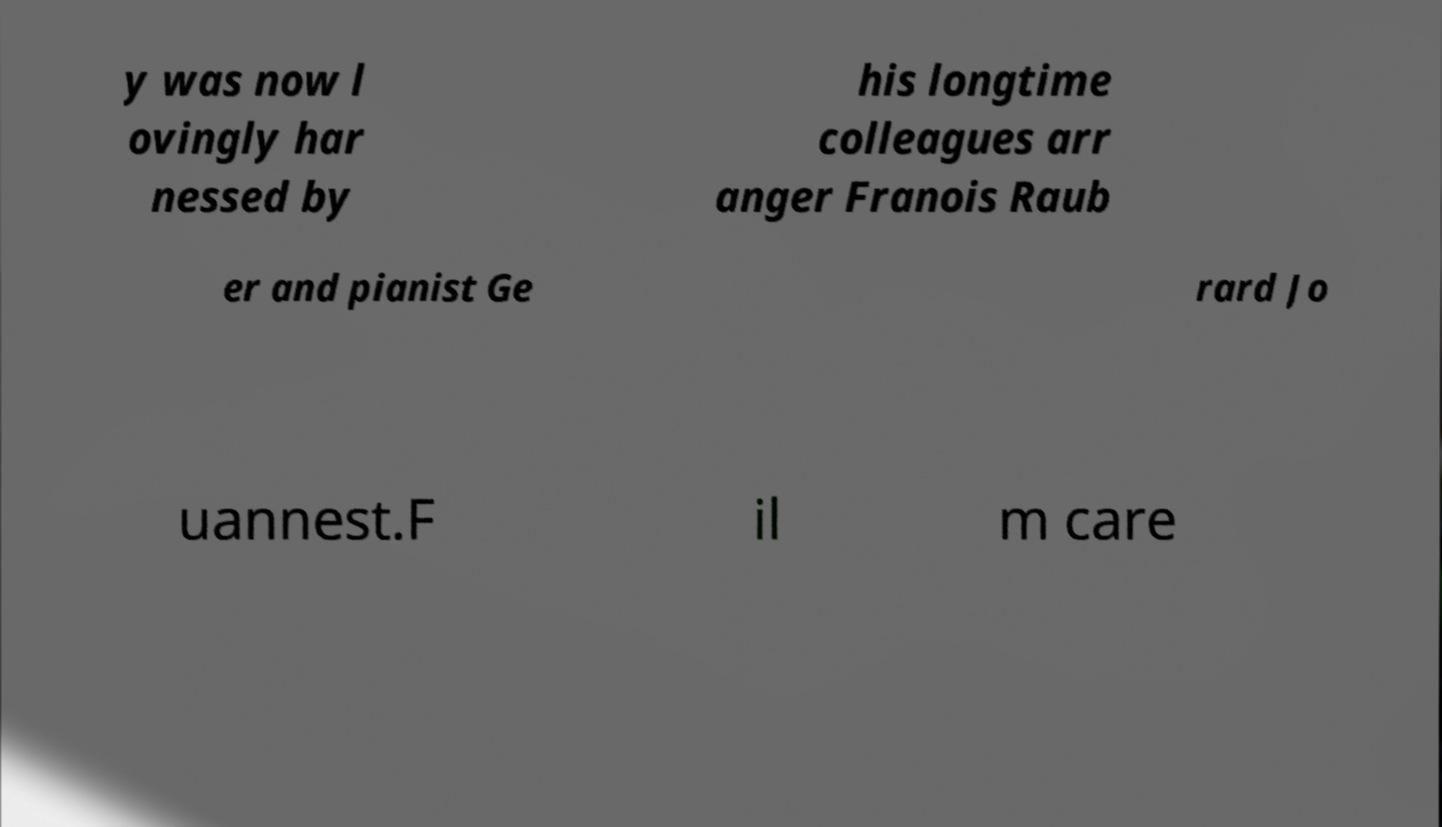I need the written content from this picture converted into text. Can you do that? y was now l ovingly har nessed by his longtime colleagues arr anger Franois Raub er and pianist Ge rard Jo uannest.F il m care 